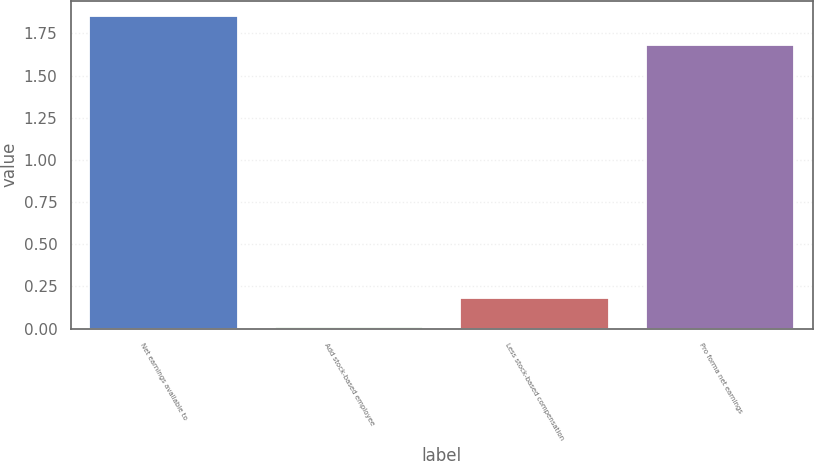Convert chart. <chart><loc_0><loc_0><loc_500><loc_500><bar_chart><fcel>Net earnings available to<fcel>Add stock-based employee<fcel>Less stock-based compensation<fcel>Pro forma net earnings<nl><fcel>1.85<fcel>0.01<fcel>0.18<fcel>1.68<nl></chart> 